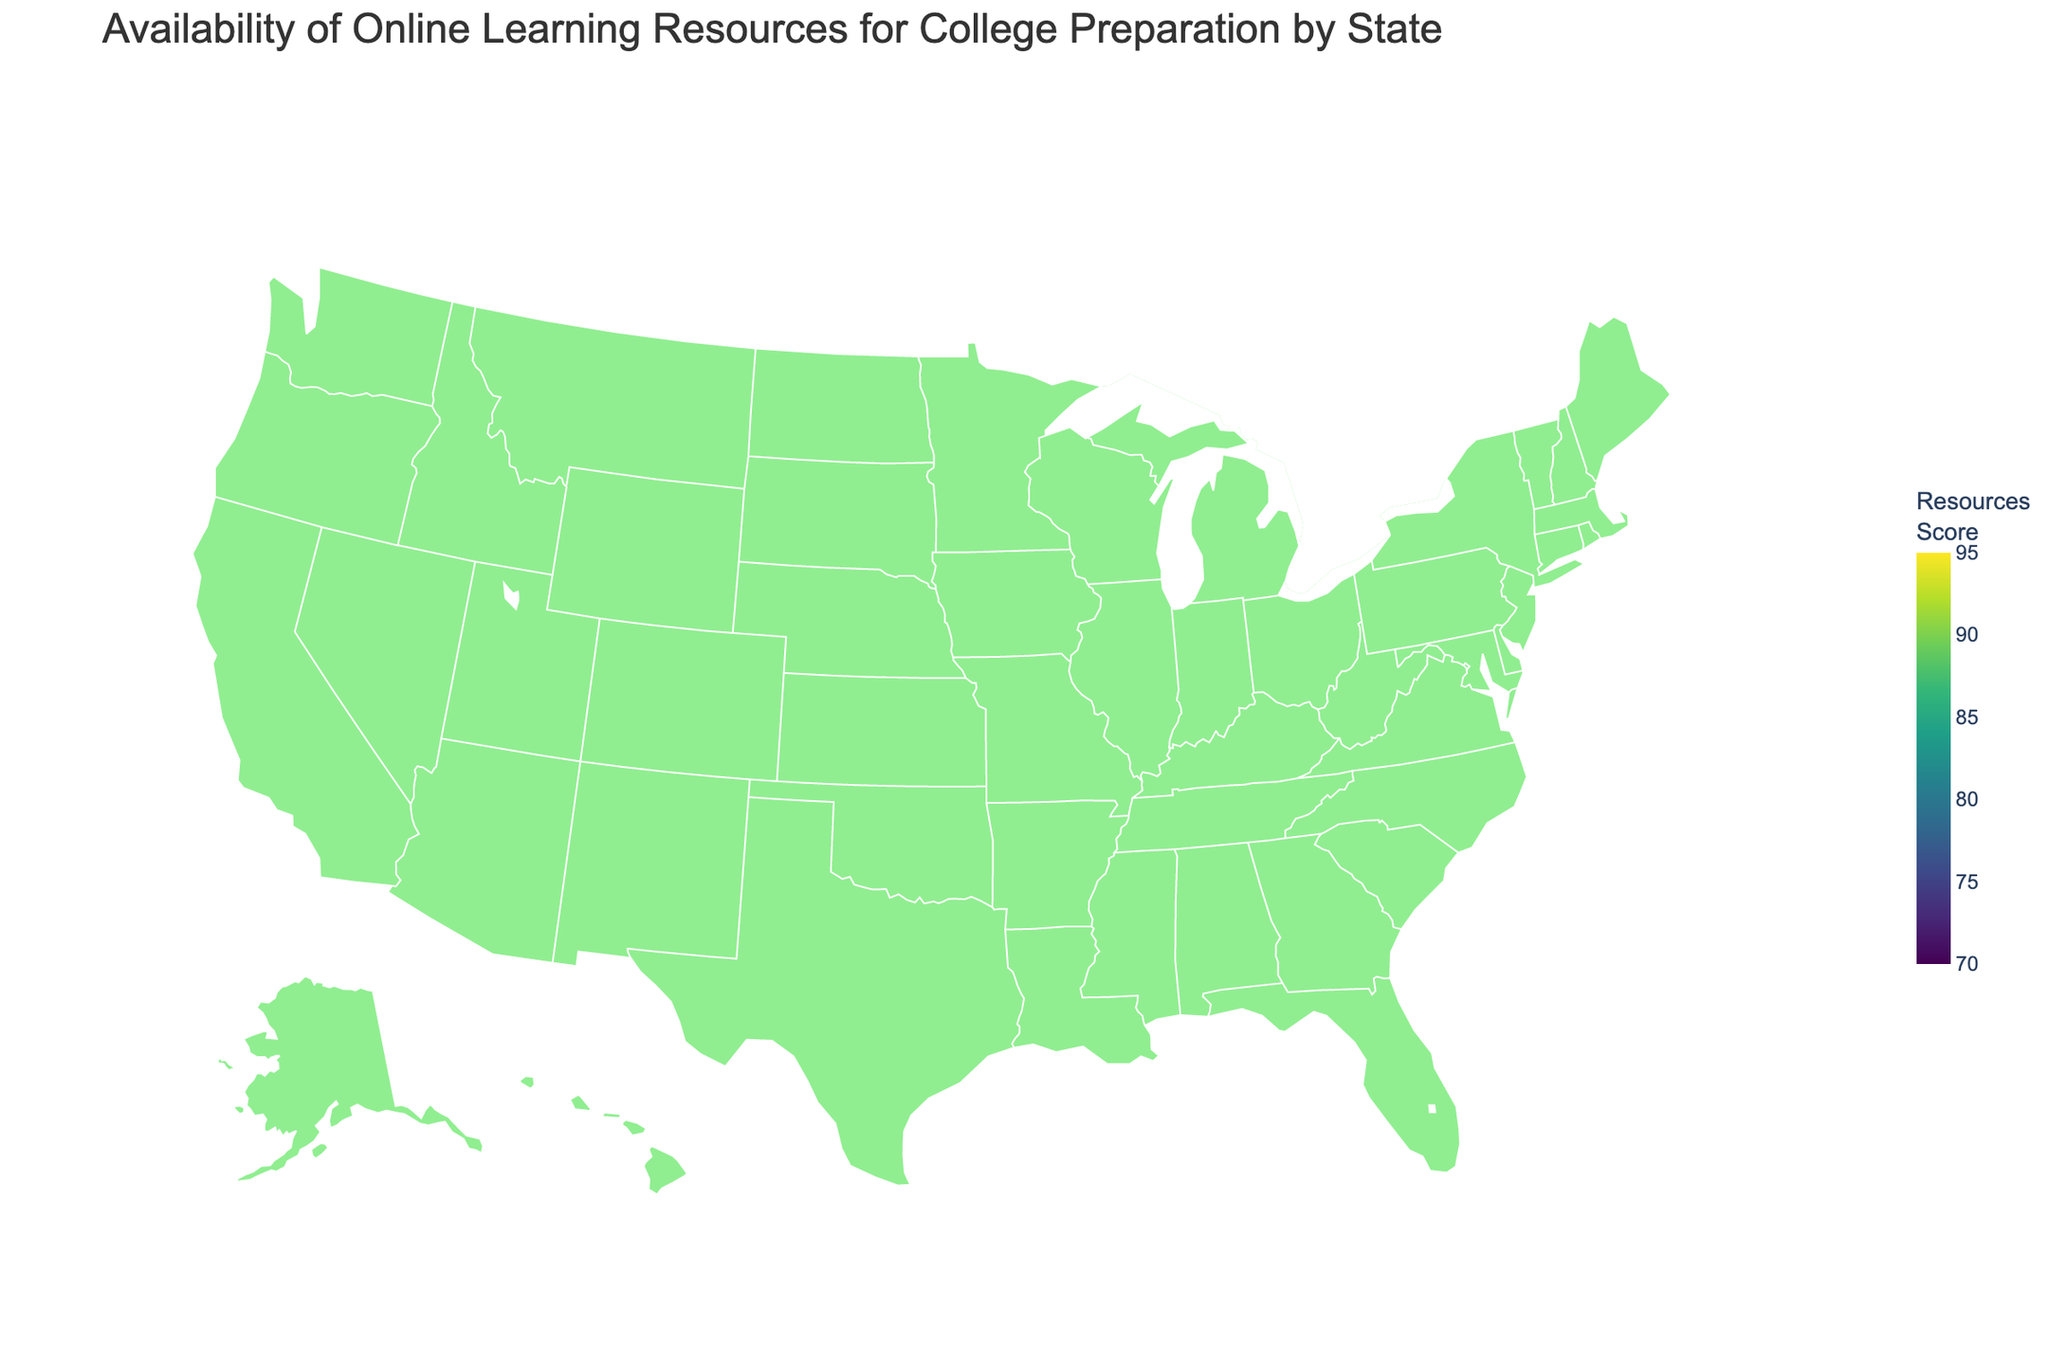What's the highest Online Learning Resources Score observed in the data? The highest score can be found by identifying the state with the darkest shade on the color scale, which correlates to higher resource scores. California has the highest score of 92 as indicated by its color.
Answer: 92 Which state has the lowest Online Learning Resources Score? The state with the lightest shade on the color scale typically has the lowest score. Indiana is represented with the lightest color, indicating its score is 76.
Answer: Indiana How many states have an Online Learning Resources Score above 85? By observing the color scale, states with a score above 85 are shaded more darkly. The states are California, New York, Massachusetts, Illinois, Washington, Colorado, and New Jersey. Counting these gives a total of 7 states.
Answer: 7 Which state has a color shade closest to New York's? Comparing the shades, Illinois and New Jersey have a color very close to New York, indicating similar scores which are around the mid-80s.
Answer: Illinois and New Jersey Is the average Online Learning Resources Score above 82? First, sum all the scores and then divide by the number of states (25). Sum = 92 + 88 + 85 + 90 + 83 + 86 + 79 + 81 + 77 + 80 + 89 + 84 + 82 + 87 + 78 + 85 + 76 + 83 + 79 + 84 + 75 + 77 + 82 + 86 + 81 = 2029. Average = 2029/25 = 81.16. Thus, it is not above 82.
Answer: No Which regions of the USA appear to have higher Online Learning Resources Scores based on the color scale? Observing the map, the West Coast (California, Washington), Northeast (New York, Massachusetts, Connecticut), and some central states like Colorado show higher scores due to their darker shades on the color scale.
Answer: West Coast, Northeast, Central What is the difference between the highest and lowest Online Learning Resources Scores? The highest score is 92 (California) and the lowest is 76 (Indiana). The difference is calculated as 92 - 76 = 16.
Answer: 16 What state in the Midwest has one of the higher Online Learning Resources Scores? Illinois, in the Midwest, has one of the higher scores with an 86. This can be determined by observing the states in the Midwest region on the map and checking their respective shades.
Answer: Illinois Do Southern states generally have higher or lower Online Learning Resources Scores? By observing the shades of Southern states like Texas, Florida, Georgia, and Tennessee which are lighter, it indicates they have scores on the lower side of the color scale.
Answer: Lower What score range is most frequently observed among the states depicted? By analyzing the shades and their distribution, most states' colors fall in the mid-range between 80 and 85 on the scale. Hence, the most frequent score range is generally in the lower to mid-80s.
Answer: 80-85 